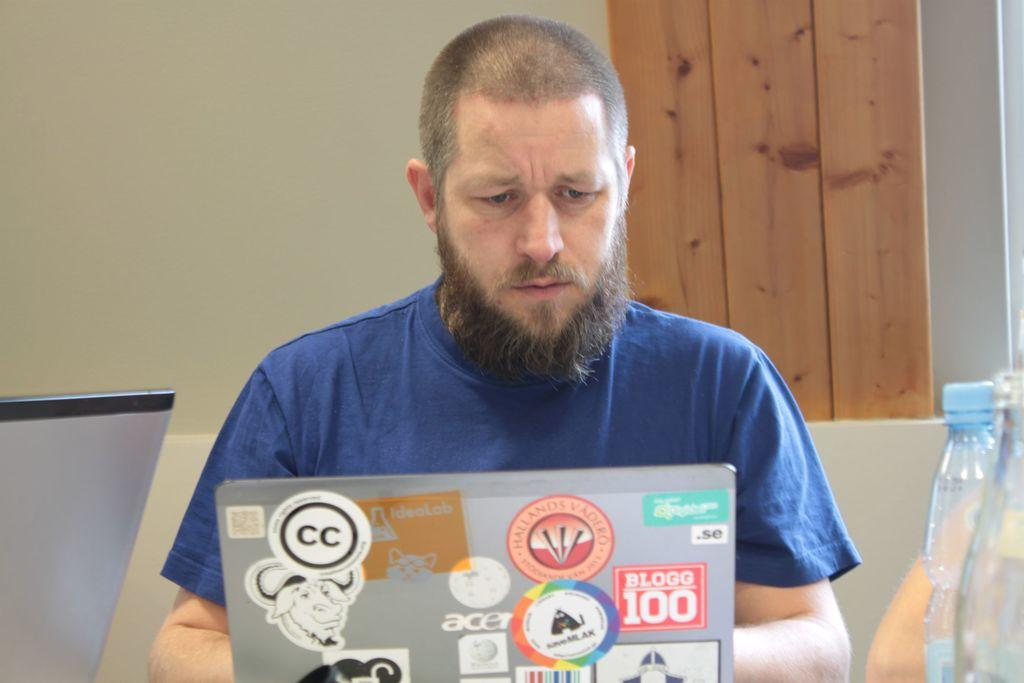What is the person in the image doing? The person is sitting in front of a laptop. What is the person wearing in the image? The person is wearing a blue t-shirt. What can be seen on the right side of the image? There are bottles on the right side of the image. What is visible in the background of the image? There is a wall and a wooden door in the background of the image. Is the person in the image stuck in quicksand? No, there is no quicksand present in the image. What type of box is being used by the person in the image? There is no box visible in the image. 